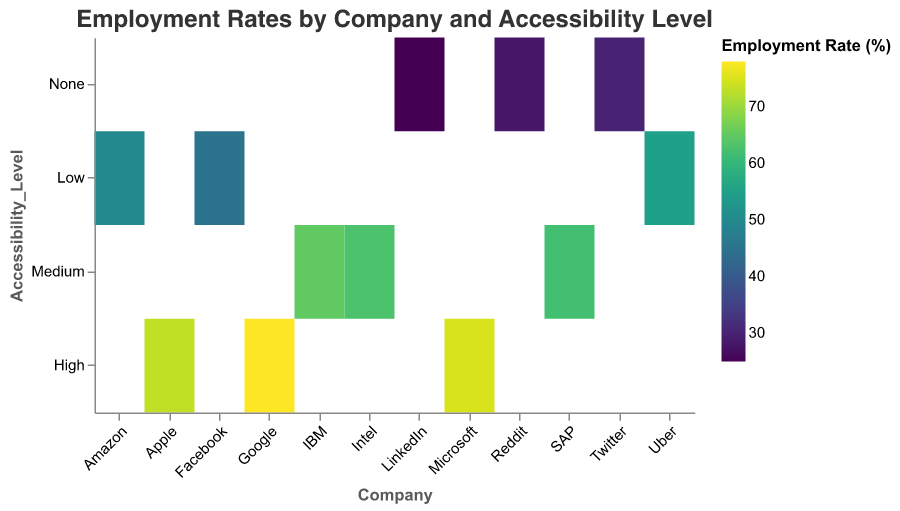What is the title of the heatmap? The title of the heatmap is prominently displayed at the top.
Answer: Employment Rates by Company and Accessibility Level Which company's employment rate is represented with the darkest color? The darkest color represents the highest employment rate value. By checking the color scale, Google has the highest employment rate at 78%.
Answer: Google How many companies fall under each accessibility level? Count the entries for each accessibility level: High has 3, Medium has 3, Low has 3, and None has 3.
Answer: 3 What is the employment rate at Amazon? Locate Amazon along the x-axis and find the corresponding color/shade, then check the legend. Amazon has an employment rate of 50%.
Answer: 50% Which accessibility level has the lowest average employment rate? Calculate the average for each accessibility level:
- None: (30 + 28 + 25)/3 = 27.67
- Low: (55 + 50 + 45)/3 = 50
- Medium: (65 + 63 + 62)/3 = 63.33
- High: (75 + 78 + 73)/3 = 75.33
The lowest average is for 'None' at 27.67%.
Answer: None What is the difference in the employment rate between the highest and lowest accessible companies? The highest rate is Google (78%) and the lowest is LinkedIn (25%). Difference: 78 - 25 = 53%.
Answer: 53% Compare the employment rates of Uber and Apple. Which is higher? Uber (Low) has an employment rate of 55% while Apple (High) is at 73%. Apple has a higher rate.
Answer: Apple What is the median employment rate for companies with a Medium accessibility level? The values are 65, 63, 62. The median value is the middle value in a sorted list, which is 63.
Answer: 63 Which company has the second-lowest employment rate? Sort employment rates from lowest to highest: LinkedIn (25), Reddit (28), Twitter (30),..., the second lowest is Reddit at 28%.
Answer: Reddit How does the employment rate for High-level accessibility compare to that of None-level accessibility? Compare the average rates calculated earlier: 
- High: 75.33%
- None: 27.67%
The rate for High accessibility is significantly higher than that of None.
Answer: Higher 